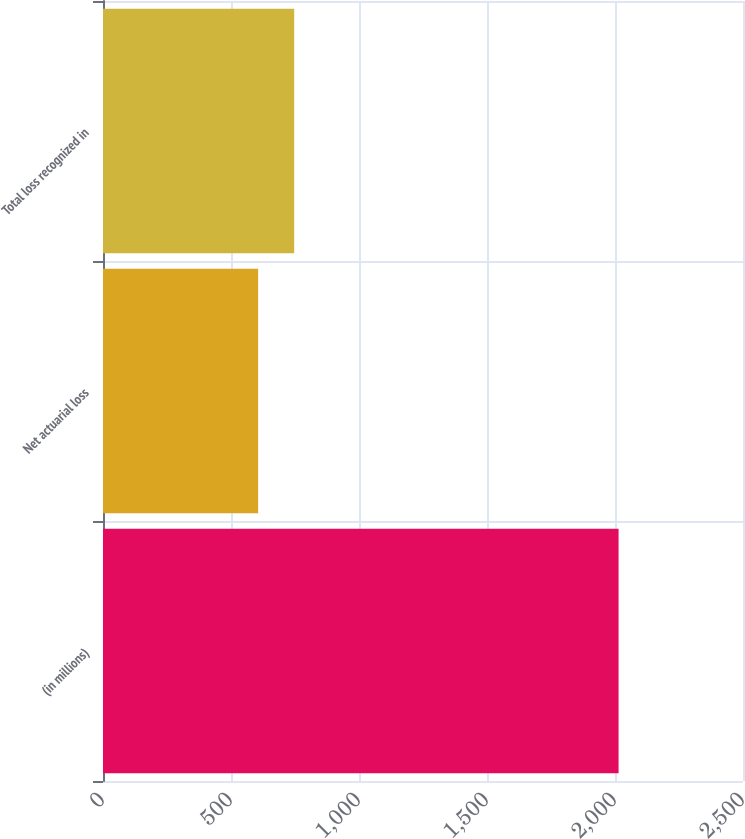Convert chart. <chart><loc_0><loc_0><loc_500><loc_500><bar_chart><fcel>(in millions)<fcel>Net actuarial loss<fcel>Total loss recognized in<nl><fcel>2014<fcel>606<fcel>746.8<nl></chart> 